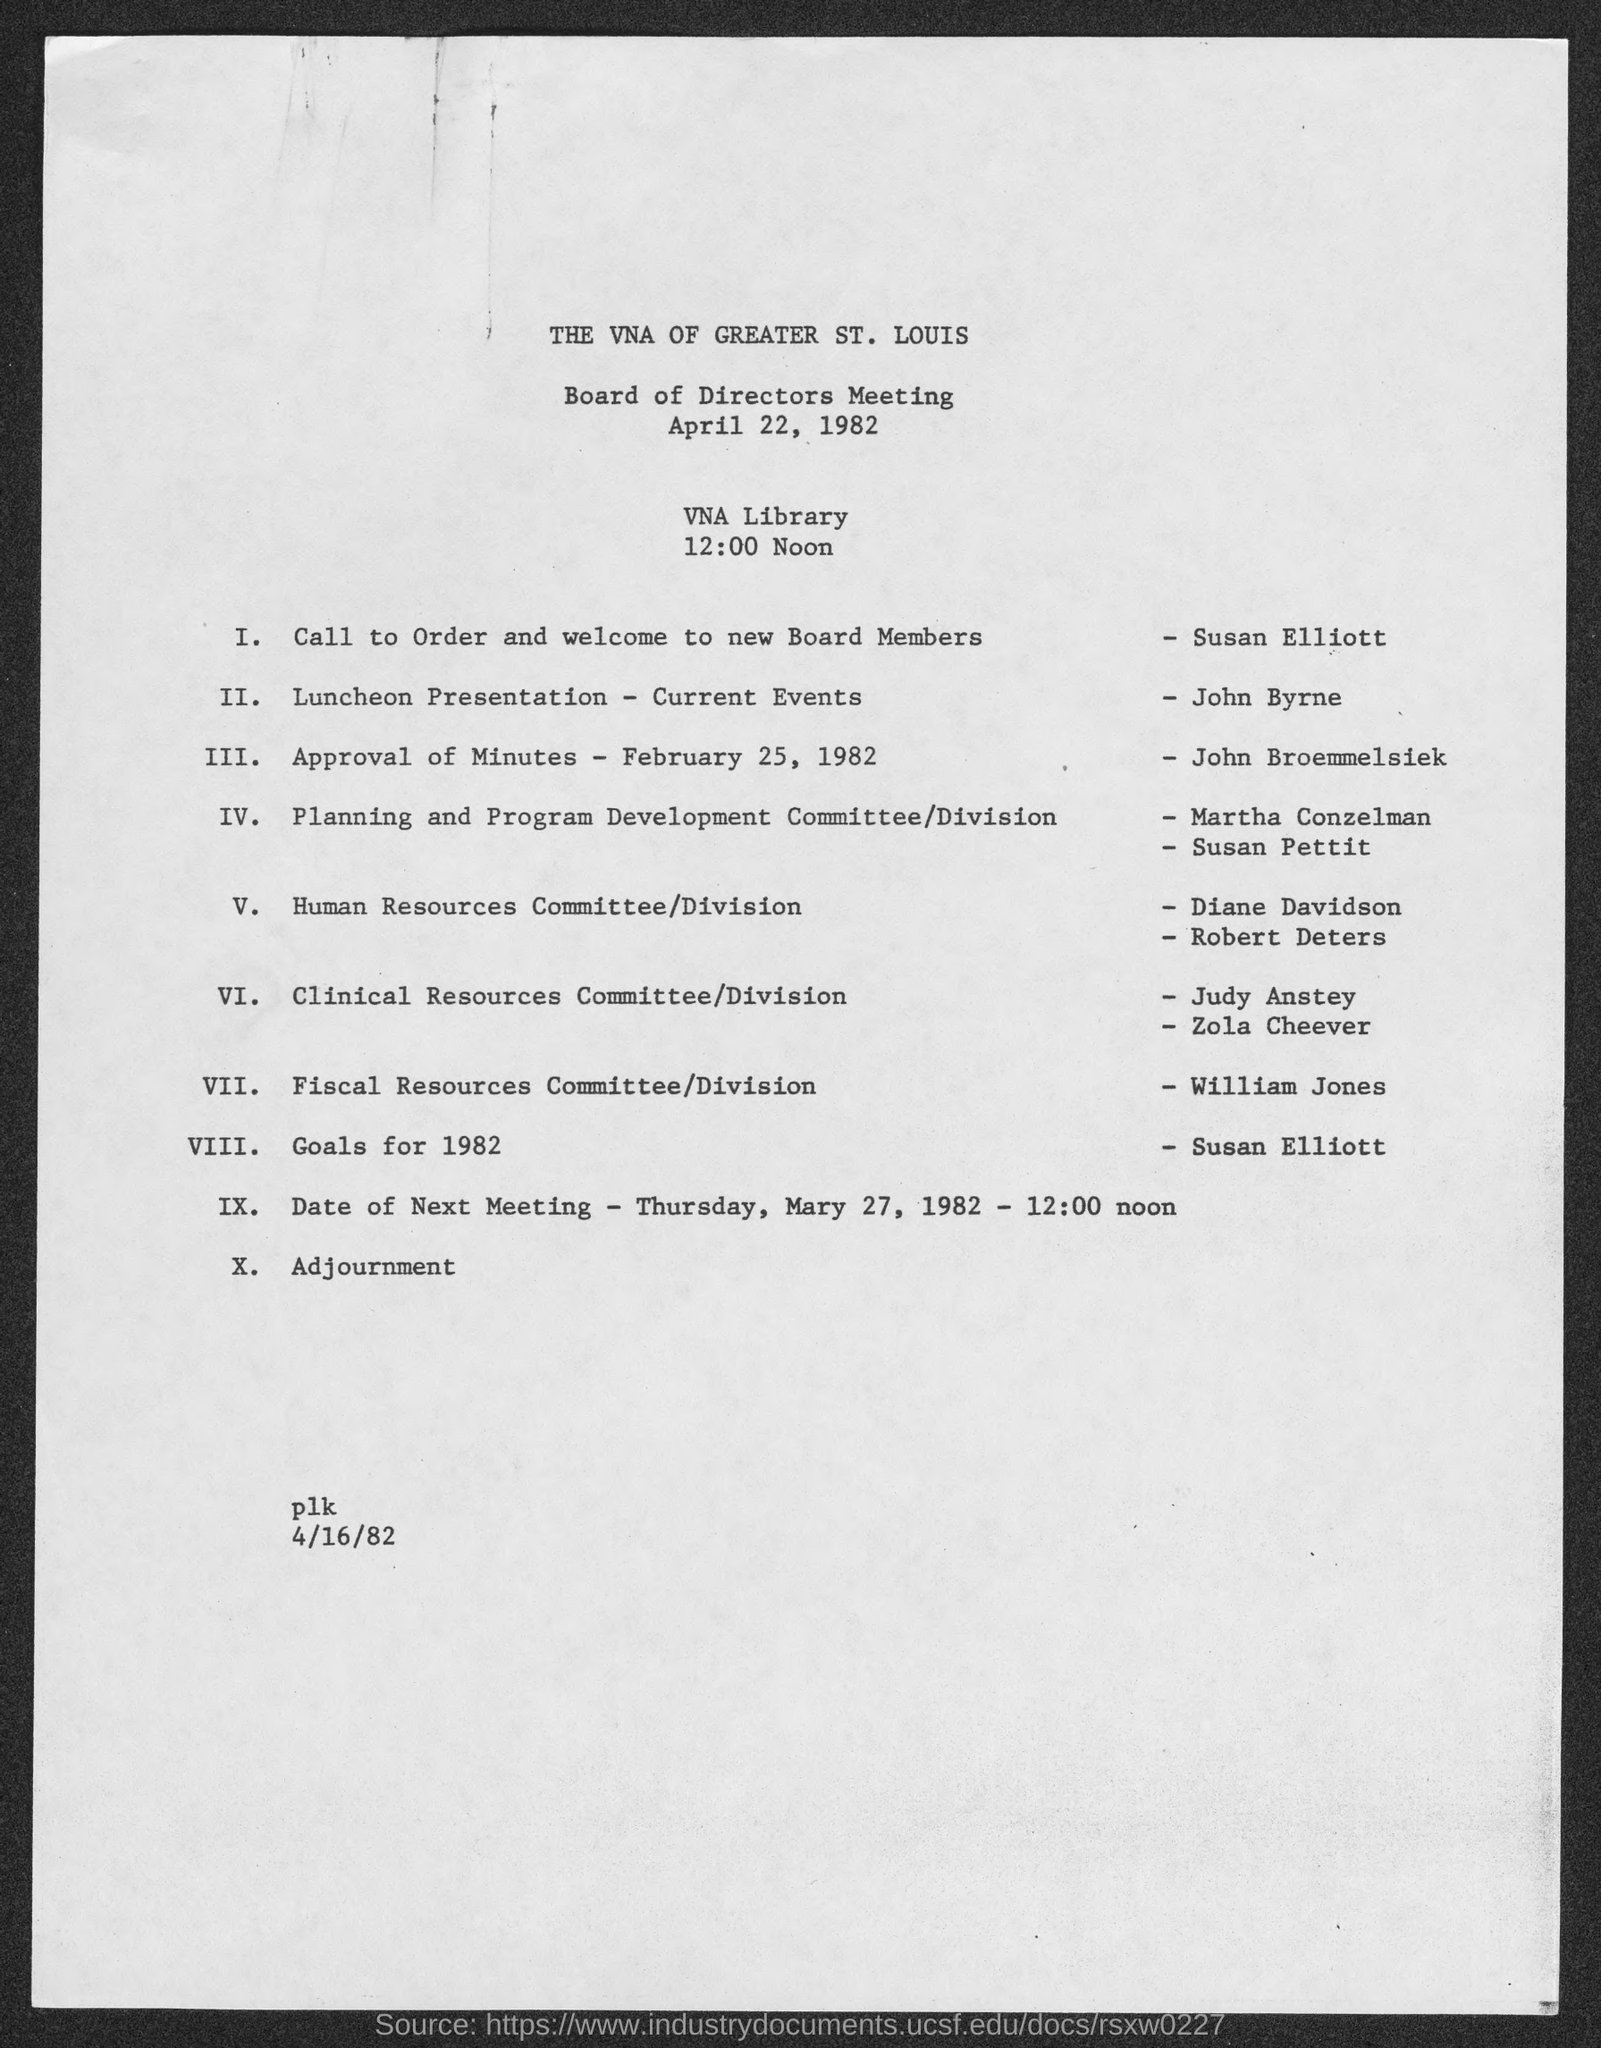Where is the Board of Directors Meeting organized?
Ensure brevity in your answer.  VNA LIBRARY. Which session is carried out by John Broemmelsiek?
Your answer should be very brief. APPROVAL OF MINUTES - FEBRUARY 25, 1982. 